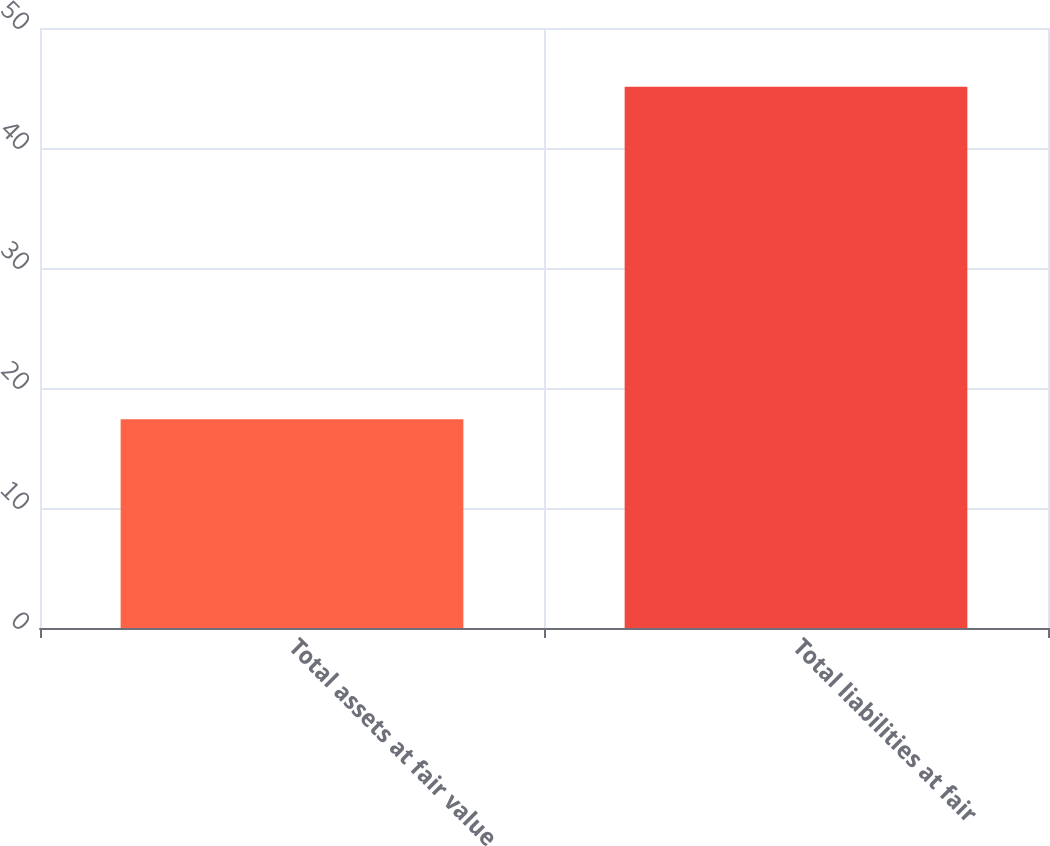Convert chart. <chart><loc_0><loc_0><loc_500><loc_500><bar_chart><fcel>Total assets at fair value<fcel>Total liabilities at fair<nl><fcel>17.4<fcel>45.1<nl></chart> 